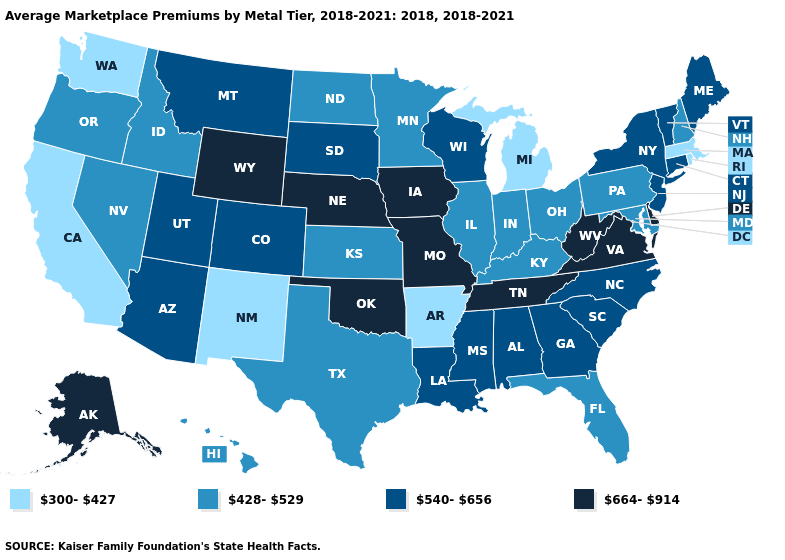Does California have the lowest value in the USA?
Be succinct. Yes. Name the states that have a value in the range 300-427?
Give a very brief answer. Arkansas, California, Massachusetts, Michigan, New Mexico, Rhode Island, Washington. What is the value of Nevada?
Answer briefly. 428-529. What is the value of Idaho?
Be succinct. 428-529. How many symbols are there in the legend?
Short answer required. 4. Does Michigan have the highest value in the MidWest?
Short answer required. No. What is the value of North Dakota?
Concise answer only. 428-529. Does Arkansas have the lowest value in the USA?
Concise answer only. Yes. Among the states that border Illinois , does Indiana have the lowest value?
Give a very brief answer. Yes. Name the states that have a value in the range 540-656?
Write a very short answer. Alabama, Arizona, Colorado, Connecticut, Georgia, Louisiana, Maine, Mississippi, Montana, New Jersey, New York, North Carolina, South Carolina, South Dakota, Utah, Vermont, Wisconsin. Which states have the lowest value in the West?
Quick response, please. California, New Mexico, Washington. What is the lowest value in the USA?
Concise answer only. 300-427. Which states hav the highest value in the MidWest?
Keep it brief. Iowa, Missouri, Nebraska. Name the states that have a value in the range 664-914?
Keep it brief. Alaska, Delaware, Iowa, Missouri, Nebraska, Oklahoma, Tennessee, Virginia, West Virginia, Wyoming. What is the lowest value in the USA?
Give a very brief answer. 300-427. 